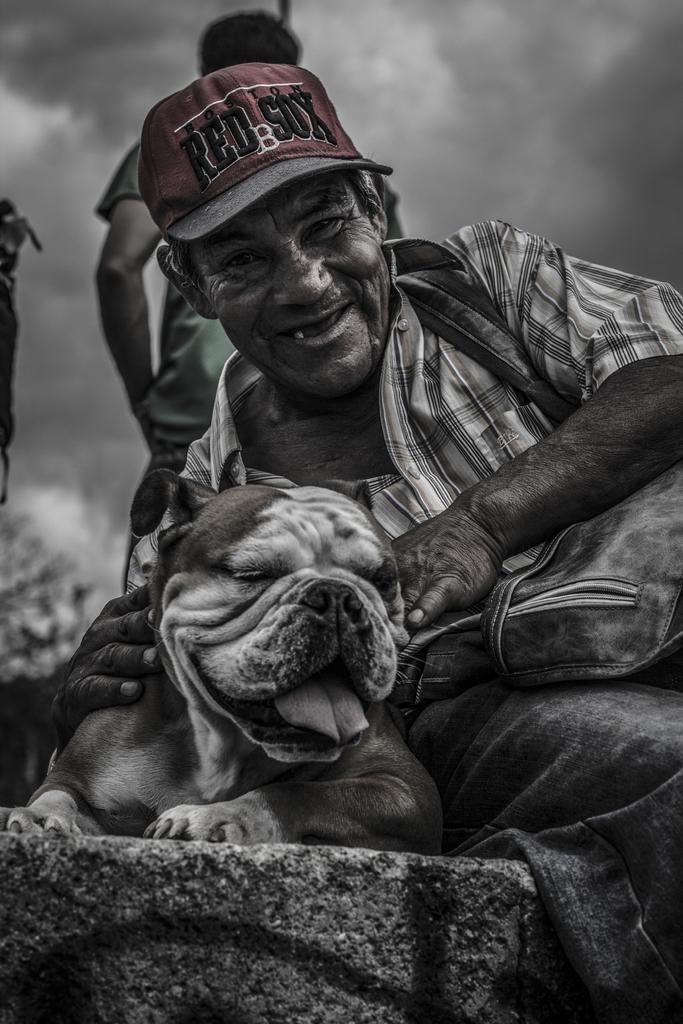Could you give a brief overview of what you see in this image? This is an graphic image,here we can see one person sitting and holding one dog. And back of him we can see another person is standing. And the background we can say the sky with clouds. 